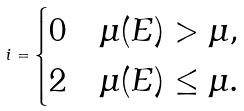Convert formula to latex. <formula><loc_0><loc_0><loc_500><loc_500>i = \begin{cases} 0 & \mu ( E ) > \mu , \\ 2 & \mu ( E ) \leq \mu . \end{cases}</formula> 